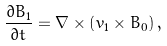Convert formula to latex. <formula><loc_0><loc_0><loc_500><loc_500>\frac { \partial { B } _ { 1 } } { \partial t } = { \nabla } \times \left ( { v } _ { 1 } \times { B } _ { 0 } \right ) ,</formula> 